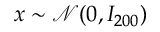<formula> <loc_0><loc_0><loc_500><loc_500>x \sim \mathcal { N } ( 0 , I _ { 2 0 0 } )</formula> 